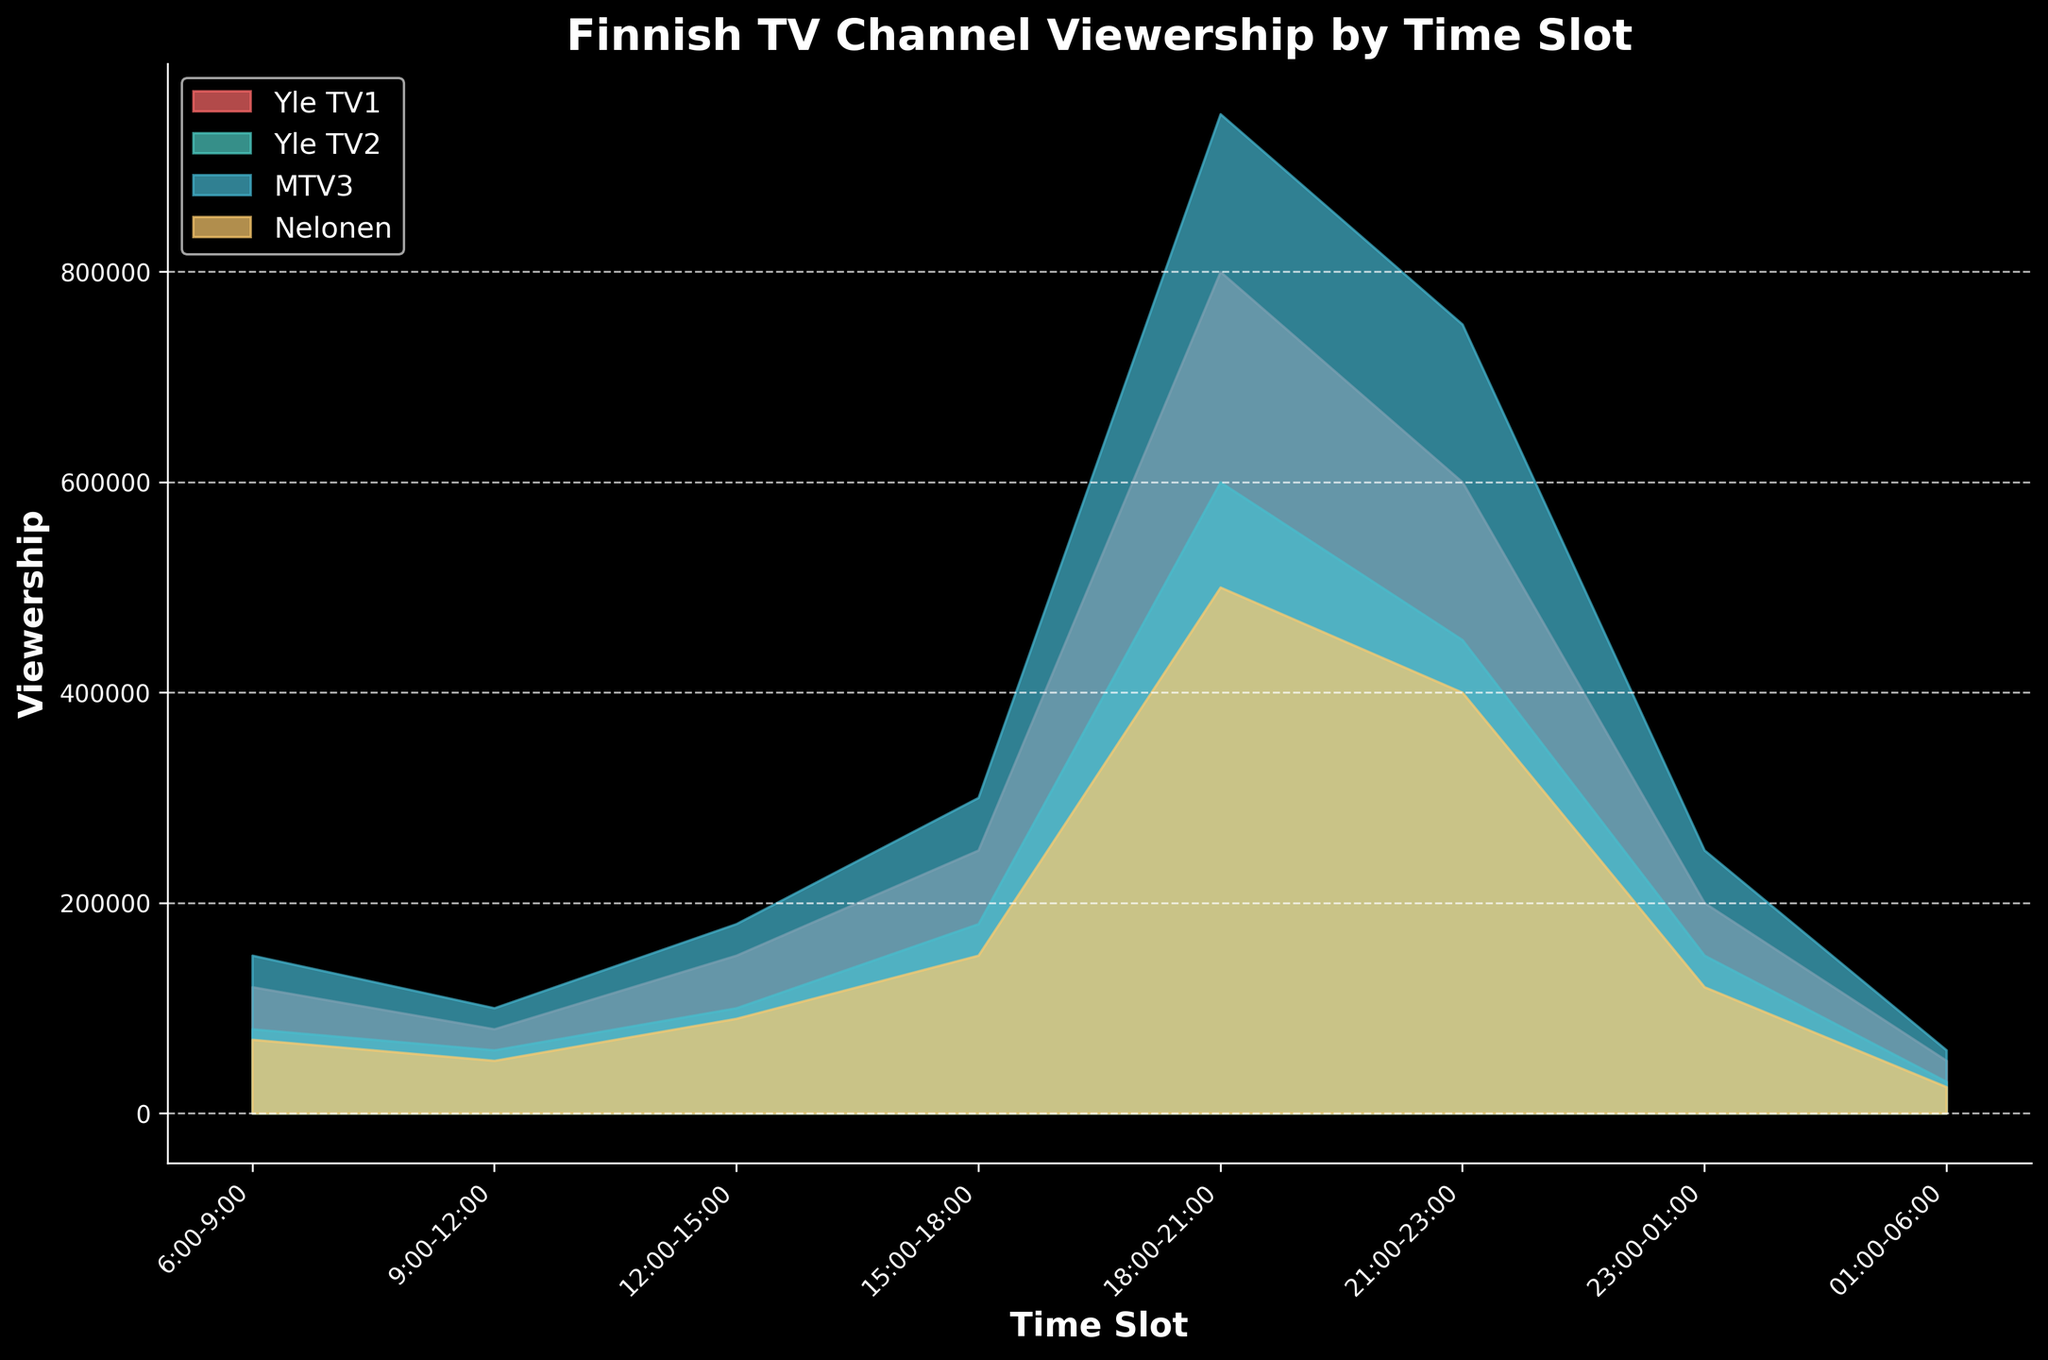Which time slot has the highest viewership on Yle TV1? Look at the curve for Yle TV1 and identify the time slot where it reaches the highest point. The highest peak for Yle TV1 is around the 18:00-21:00 time slot.
Answer: 18:00-21:00 How is the total viewership from 18:00 to 21:00 compared between Yle TV1 and MTV3? Observe the heights of the curves for Yle TV1 and MTV3 in the 18:00-21:00 time slot and compare their values. Yle TV1 has 800,000 viewers while MTV3 has 950,000.
Answer: MTV3 Which channel has the lowest viewership during 01:00-06:00? Find the values for each channel during the 01:00-06:00 time slot and identify the minimum. Nelonen has the lowest viewership with 25,000 viewers.
Answer: Nelonen What is the combined viewership for all channels during the 21:00-23:00 time slot? Sum the viewership numbers for Yle TV1 (600,000), Yle TV2 (450,000), MTV3 (750,000), and Nelonen (400,000) during this time slot. The total is 600,000 + 450,000 + 750,000 + 400,000.
Answer: 2,200,000 During which time slot does Yle TV2 have a viewership higher than Nelonen but lower than MTV3? Compare the viewership numbers for Yle TV2, Nelonen, and MTV3 across all time slots. The only slot where Yle TV2 fits the criteria is 15:00-18:00 (180,000 > 150,000 but < 300,000).
Answer: 15:00-18:00 How does the viewership trend for Nelonen change from morning (6:00-9:00) to late night (23:00-1:00)? Observe the points representing the viewership of Nelonen from morning through late night. There is an increase from 6:00-9:00 (70,000) to 21:00-23:00 (400,000), followed by a sharp decrease to 23:00-1:00 (120,000).
Answer: Initial increase then sharp decrease What's the difference in viewership between the peak hours of Yle TV1 and the peak hours of MTV3? Identify the peak viewership values for Yle TV1 (18:00-21:00, 800,000) and MTV3 (18:00-21:00, 950,000), then calculate the difference. Subtract Yle TV1's peak from MTV3's peak.
Answer: 150,000 Which channel consistently has higher viewership during the 15:00-18:00 and 18:00-21:00 time slots? Compare the viewership values across these time slots. MTV3 has higher or equally high values both times (300,000; 950,000).
Answer: MTV3 